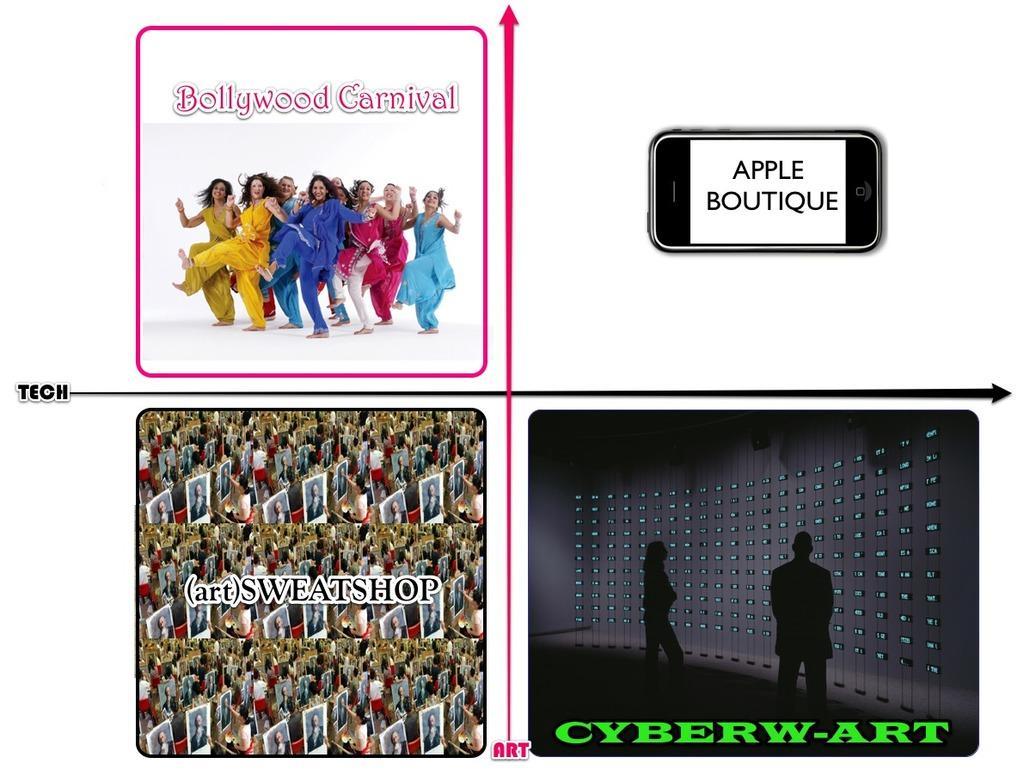Describe this image in one or two sentences. This image is a collage of four pictures in the first one there are so many people dancing in the second one there is a mobile phone and in third image there are photo of so many people and in fourth image there is a shadow of man and woman on the lockers. 